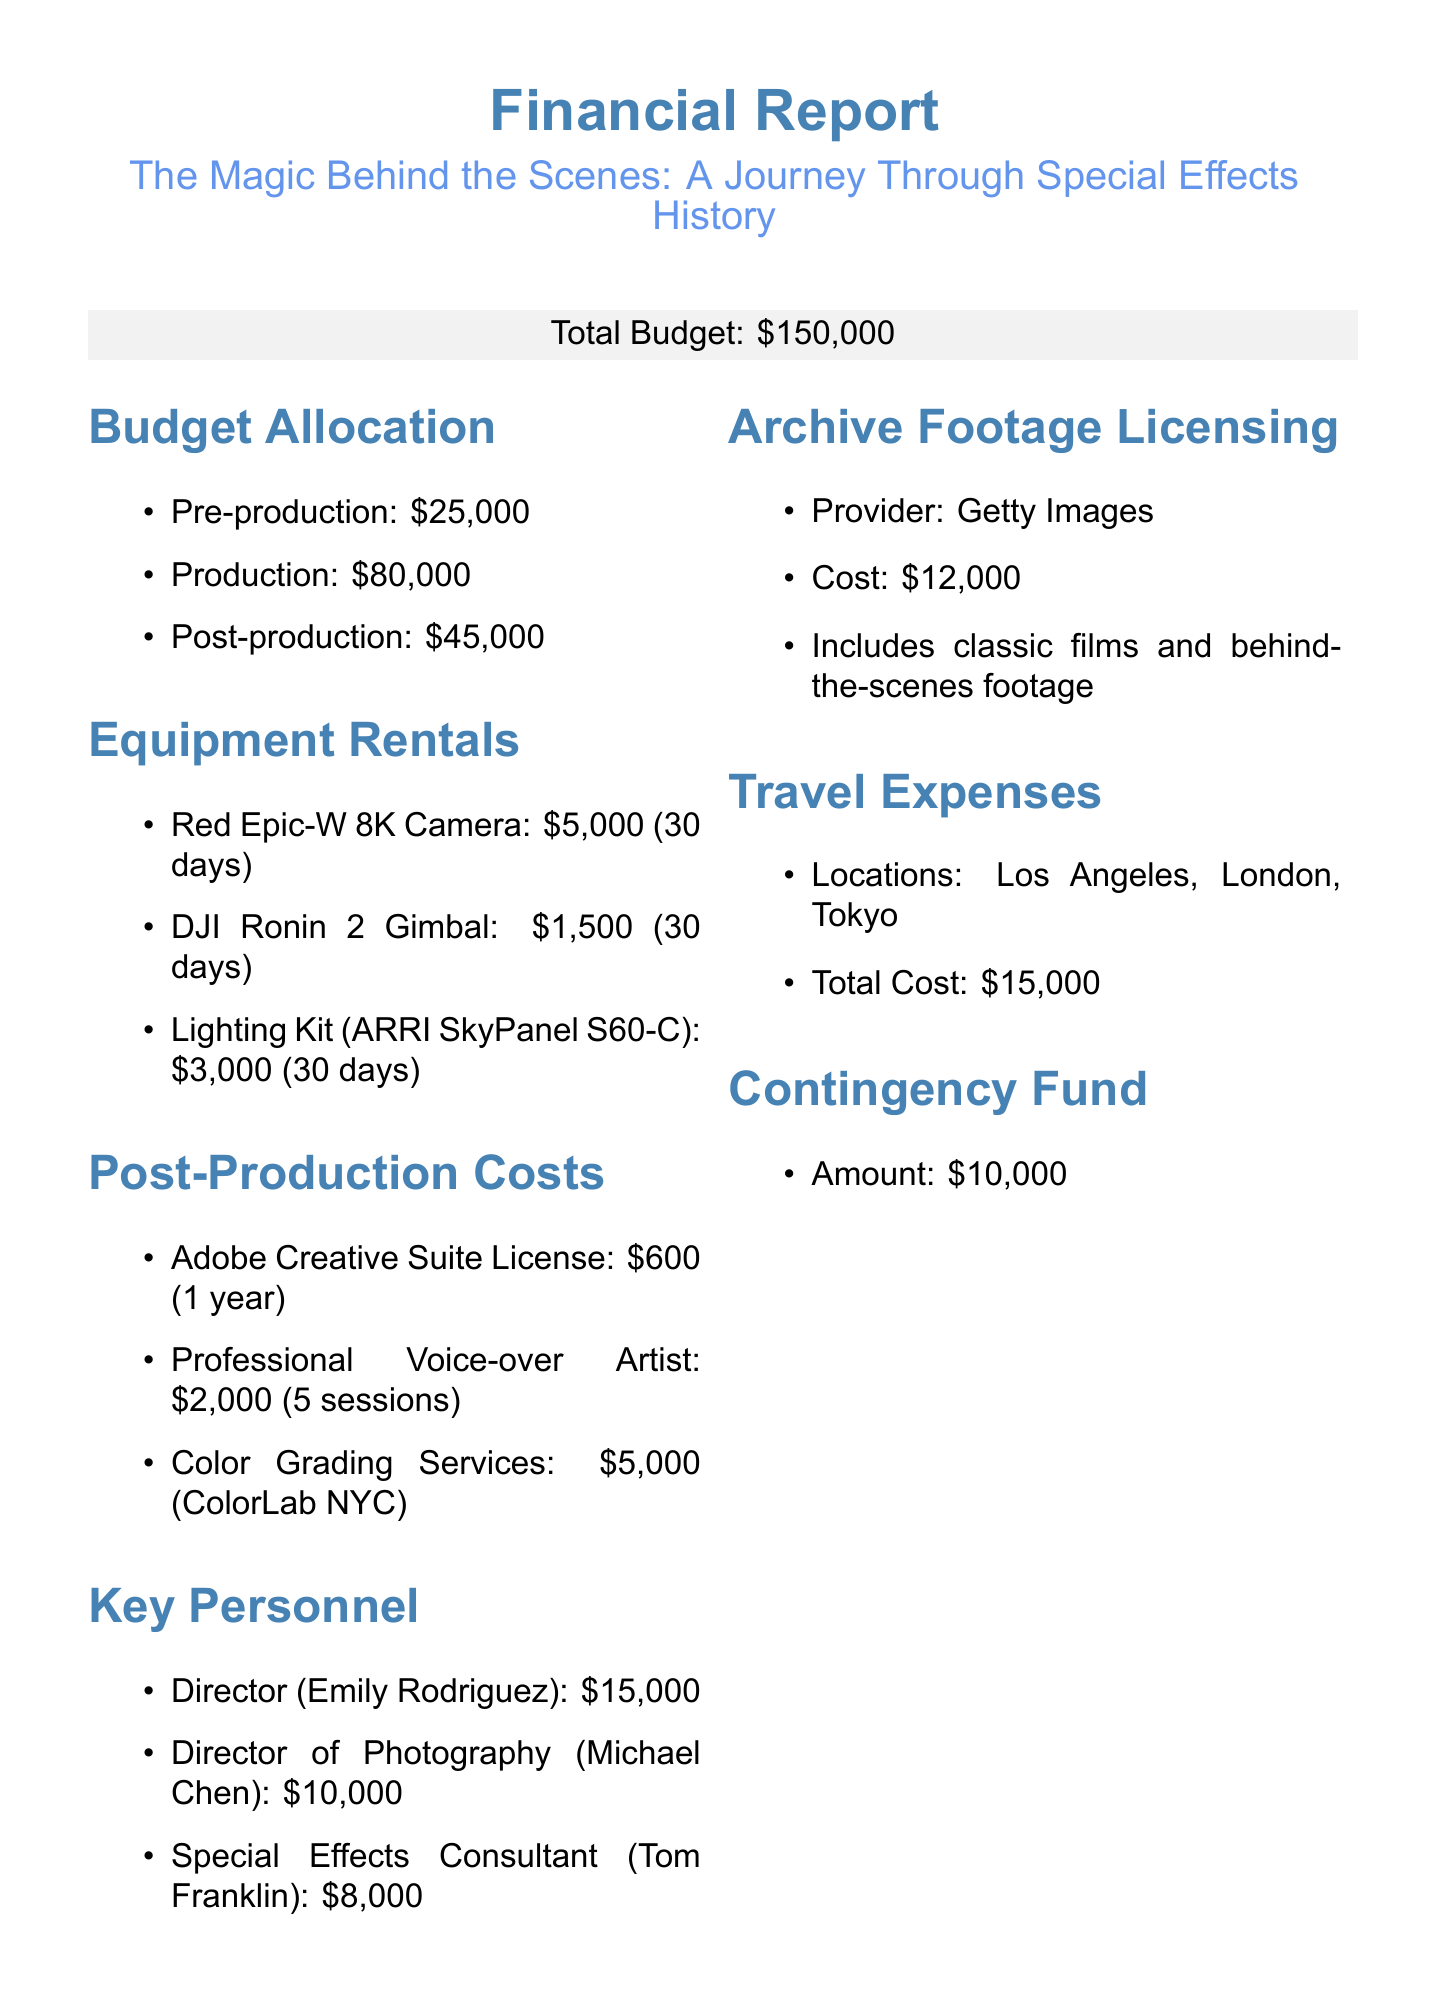What is the total budget? The total budget for the documentary film project is explicitly stated in the document.
Answer: $150,000 How much is allocated for production? The budget allocation section lists the amount specifically designated for production costs.
Answer: $80,000 Who is the Director of Photography? The key personnel section mentions the name of the Director of Photography along with their role and fee.
Answer: Michael Chen What is the cost of Color Grading Services? The post-production costs section provides the specific expenses related to services, including Color Grading.
Answer: $5,000 What are the travel locations mentioned? The travel expenses section lists the different locations associated with travel for the documentary project.
Answer: Los Angeles, London, Tokyo How much is dedicated to the contingency fund? The document includes a specific section that clearly states the amount allocated for the contingency fund.
Answer: $10,000 What is the fee for the Special Effects Consultant? The key personnel section provides the fee for the role of Special Effects Consultant, which is listed.
Answer: $8,000 What is the licensing provider for archive footage? The section on archive footage licensing specifies the provider who is granting the licenses necessary for the footage.
Answer: Getty Images How many sessions are included with the Professional Voice-over Artist? The post-production costs indicate the number of recording sessions included in the cost for the Professional Voice-over Artist.
Answer: 5 recording sessions 